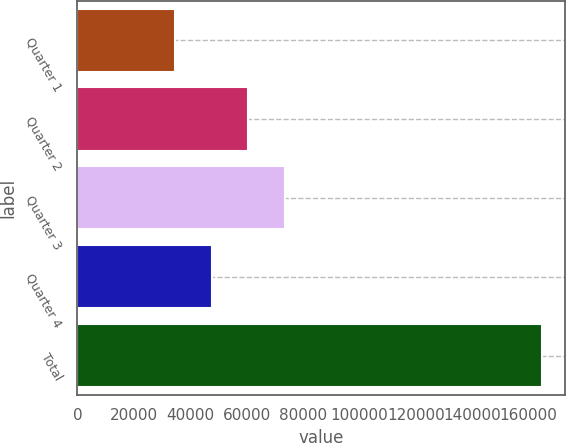<chart> <loc_0><loc_0><loc_500><loc_500><bar_chart><fcel>Quarter 1<fcel>Quarter 2<fcel>Quarter 3<fcel>Quarter 4<fcel>Total<nl><fcel>34681<fcel>60677<fcel>73675<fcel>47679<fcel>164661<nl></chart> 